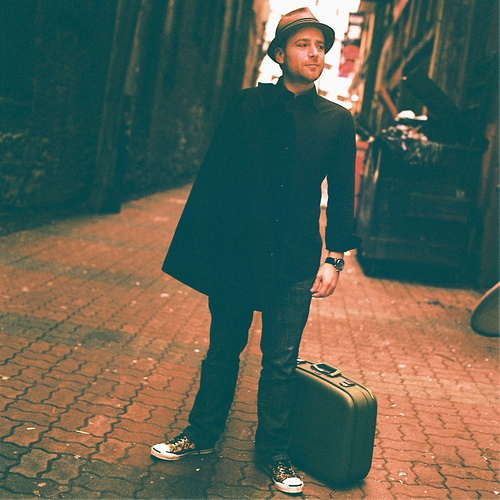Describe the objects in this image and their specific colors. I can see people in teal, gray, and salmon tones and suitcase in teal, gray, and tan tones in this image. 